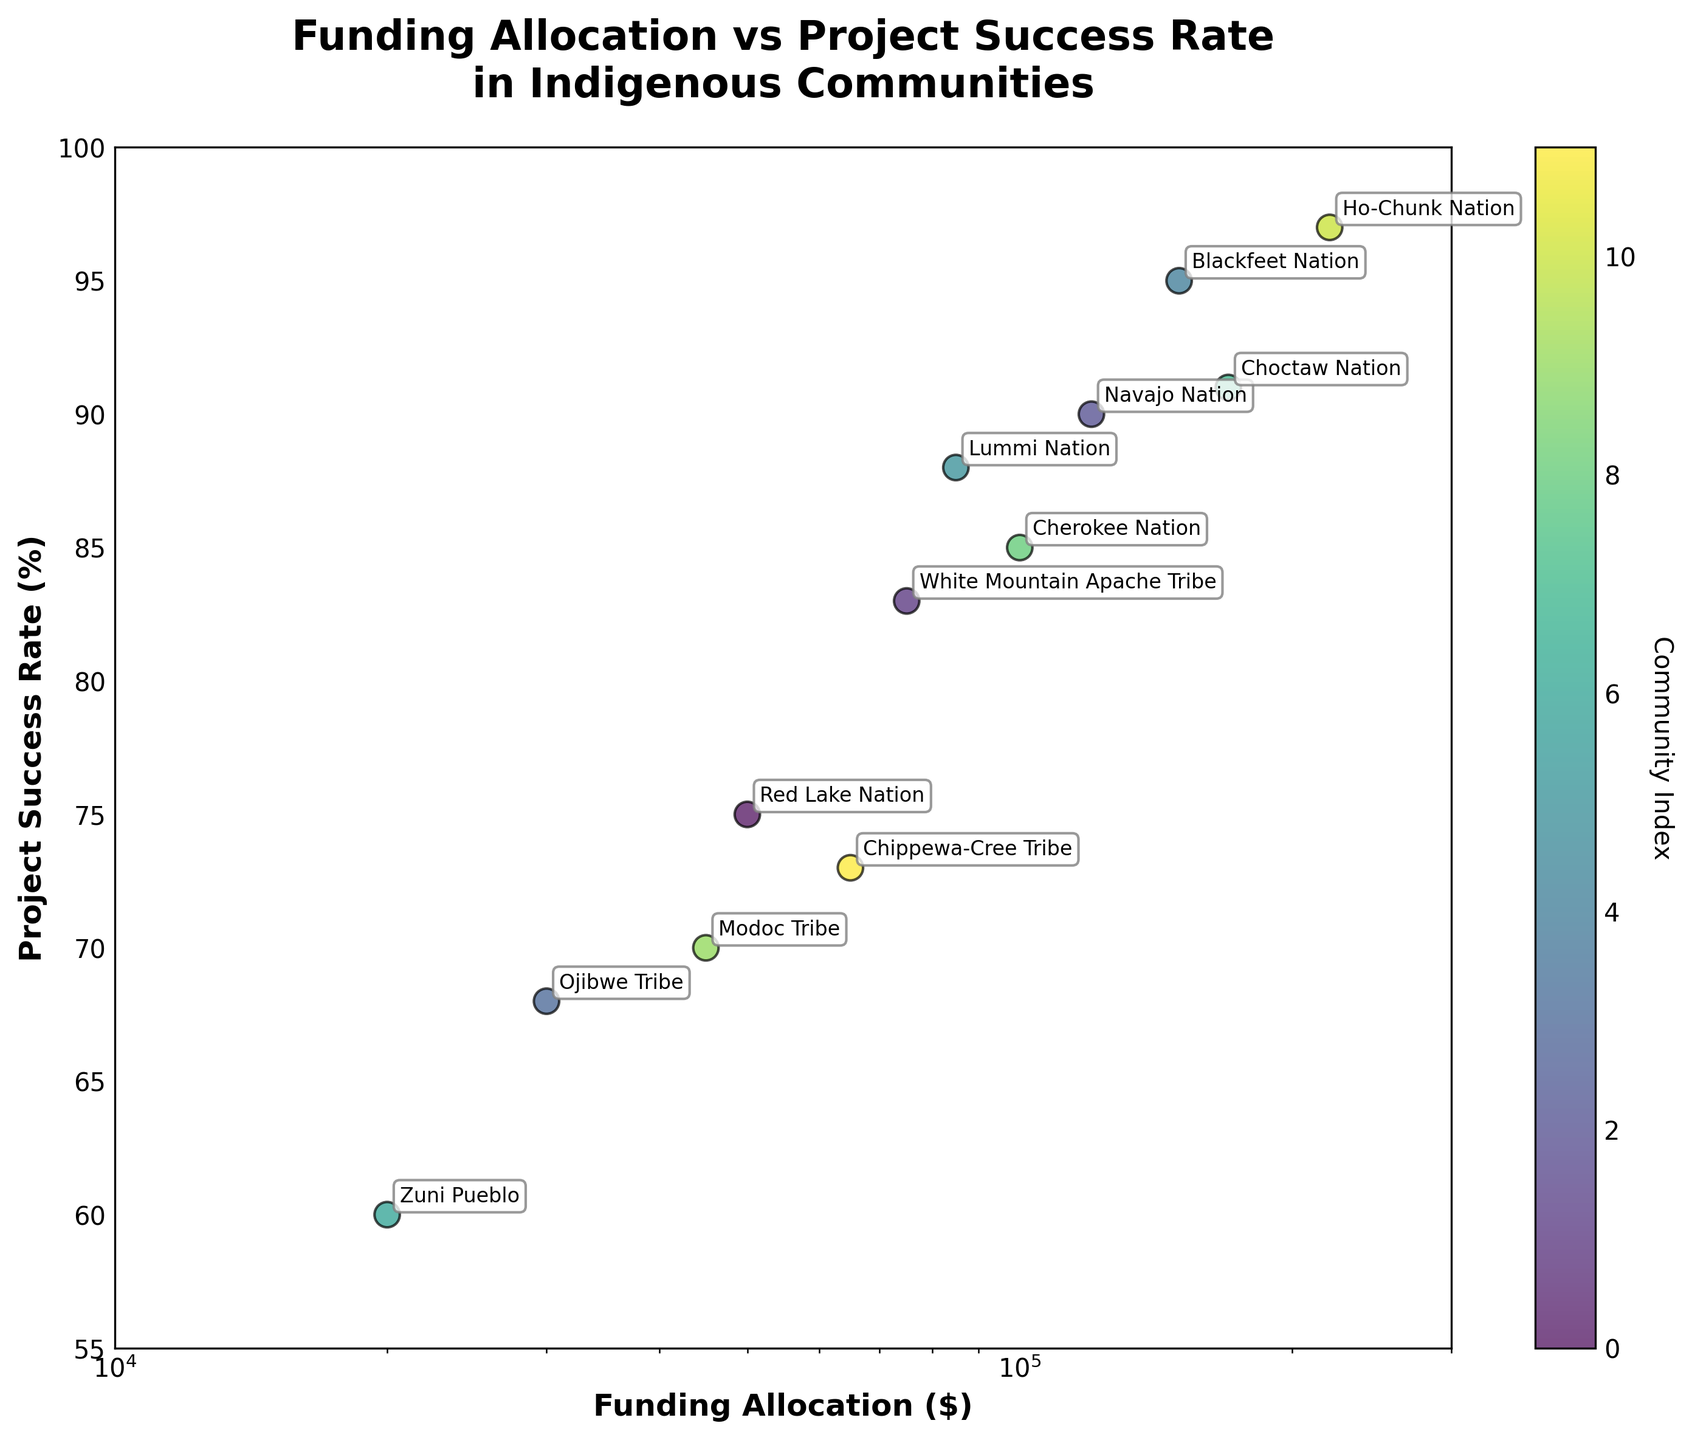What is the title of the figure? The title is usually at the top of the figure. In this case, it is bold and centered.
Answer: Funding Allocation vs Project Success Rate in Indigenous Communities What are the x-axis and y-axis labels? The x-axis and y-axis labels need to be found next to the respective axes. The x-axis label is at the bottom and the y-axis label is on the left side of the plot.
Answer: x-axis: Funding Allocation ($), y-axis: Project Success Rate (%) Which community has the highest project success rate? You need to find the point with the highest y-value and look at the annotation next to it.
Answer: Ho-Chunk Nation What is the funding allocation for the Zuni Pueblo community? Find the data point labeled 'Zuni Pueblo' and read off its x-value.
Answer: 20000 What is the project success rate for the Modoc Tribe community? Locate the data point labeled 'Modoc Tribe' and check its y-value.
Answer: 70 Which community received the highest funding allocation? Identify the point with the highest x-value and find the corresponding annotation.
Answer: Ho-Chunk Nation Which two communities have a project success rate of 85%? Look for points on the plot where the y-value is 85% and see which communities are labeled there.
Answer: Cherokee Nation What is the difference in funding allocation between the Navajo Nation and the Choctaw Nation? Find the x-values corresponding to the 'Navajo Nation' and 'Choctaw Nation' and subtract the smaller value from the larger one.
Answer: 170000-120000=50000 Calculate the average project success rate for the Red Lake Nation, Ojibwe Tribe, and Zuni Pueblo communities. Find the y-values for these communities, sum them up, and divide by the number of communities (3).
Answer: (75 + 68 + 60) / 3 = 67.67 How many communities have a funding allocation greater than $100,000? Identify the data points with x-values greater than 100000 and count them.
Answer: 4 